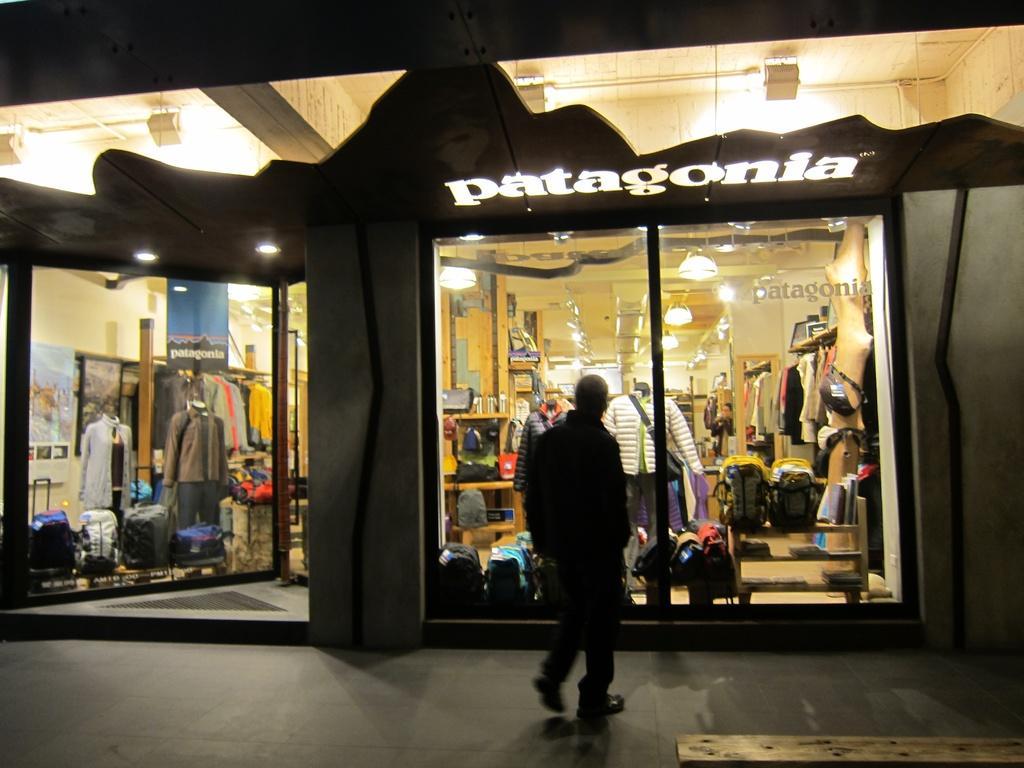Describe this image in one or two sentences. In this picture we can see a person standing in front of the window of an apparel store with many clothes & bags in the display. We can see lights on the ceiling. 